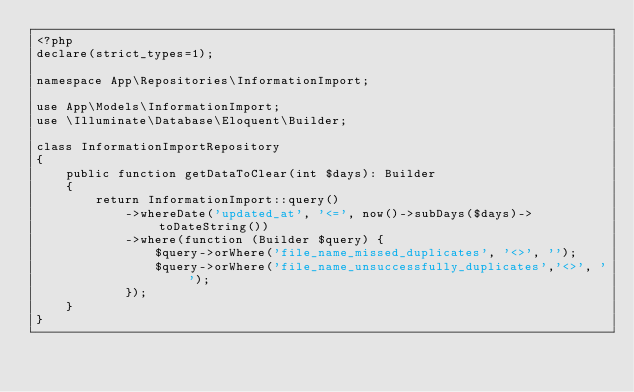<code> <loc_0><loc_0><loc_500><loc_500><_PHP_><?php
declare(strict_types=1);

namespace App\Repositories\InformationImport;

use App\Models\InformationImport;
use \Illuminate\Database\Eloquent\Builder;

class InformationImportRepository
{
    public function getDataToClear(int $days): Builder
    {
        return InformationImport::query()
            ->whereDate('updated_at', '<=', now()->subDays($days)->toDateString())
            ->where(function (Builder $query) {
                $query->orWhere('file_name_missed_duplicates', '<>', '');
                $query->orWhere('file_name_unsuccessfully_duplicates','<>', '');
            });
    }
}
</code> 